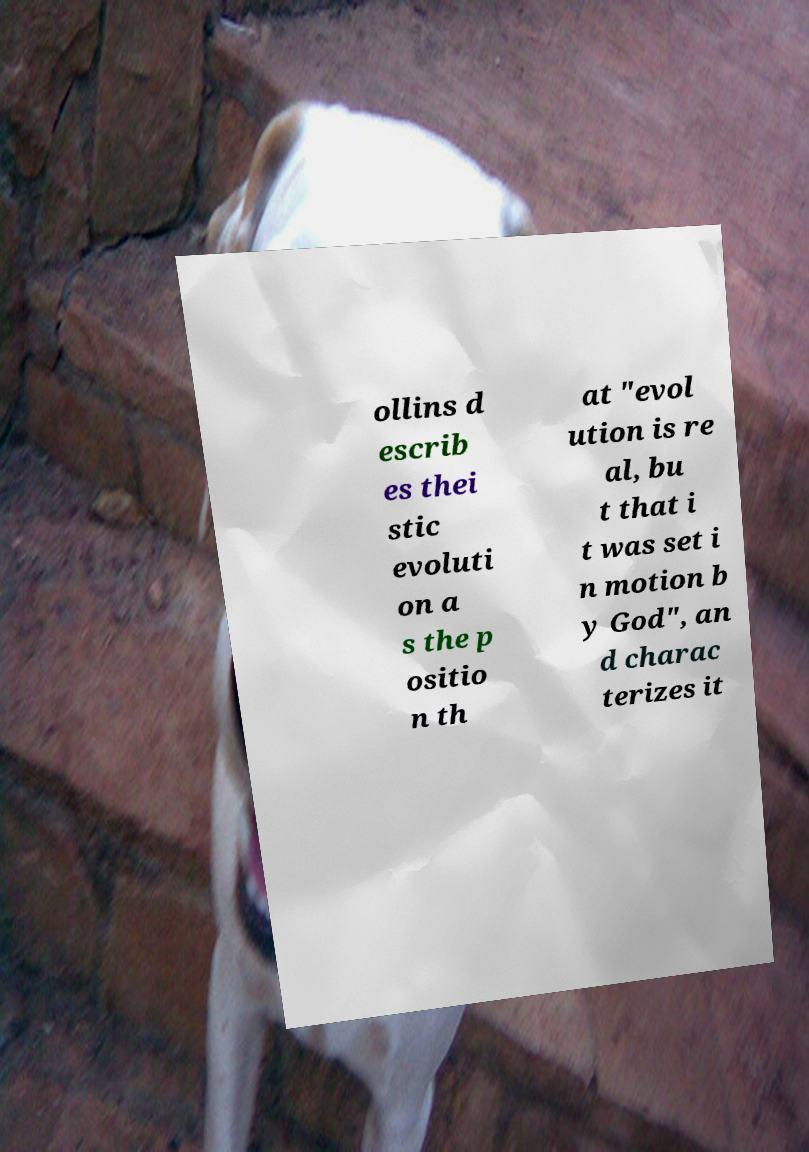What messages or text are displayed in this image? I need them in a readable, typed format. ollins d escrib es thei stic evoluti on a s the p ositio n th at "evol ution is re al, bu t that i t was set i n motion b y God", an d charac terizes it 